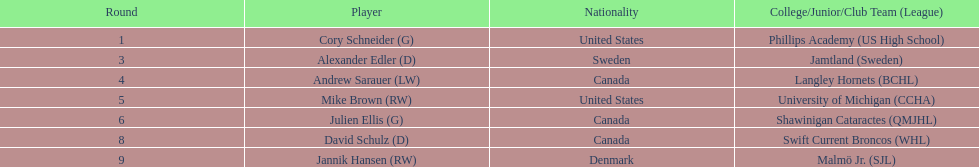How many players were from the united states? 2. 